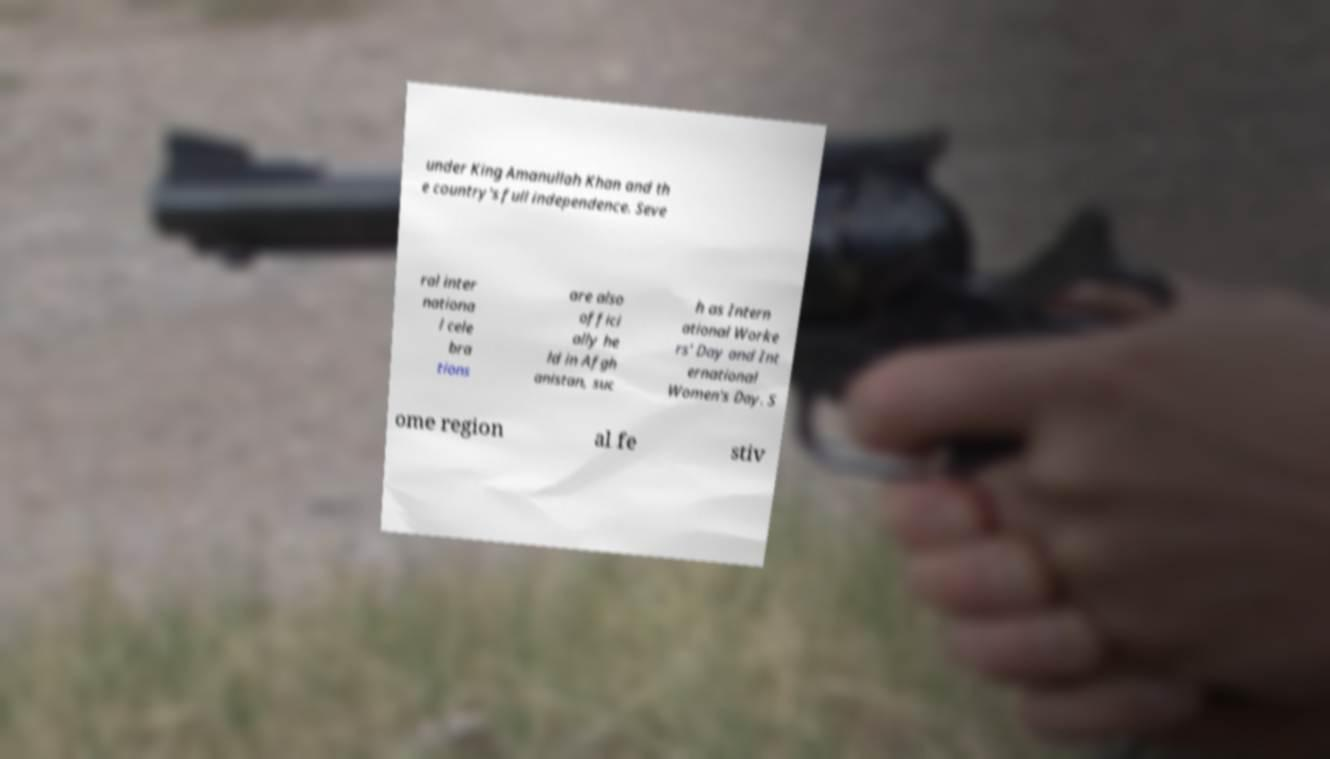Could you extract and type out the text from this image? under King Amanullah Khan and th e country's full independence. Seve ral inter nationa l cele bra tions are also offici ally he ld in Afgh anistan, suc h as Intern ational Worke rs' Day and Int ernational Women's Day. S ome region al fe stiv 